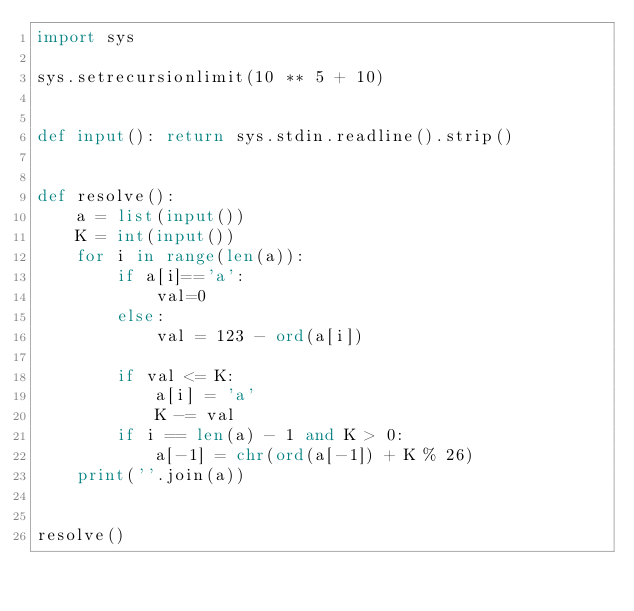<code> <loc_0><loc_0><loc_500><loc_500><_Python_>import sys

sys.setrecursionlimit(10 ** 5 + 10)


def input(): return sys.stdin.readline().strip()


def resolve():
    a = list(input())
    K = int(input())
    for i in range(len(a)):
        if a[i]=='a':
            val=0
        else:
            val = 123 - ord(a[i])

        if val <= K:
            a[i] = 'a'
            K -= val
        if i == len(a) - 1 and K > 0:
            a[-1] = chr(ord(a[-1]) + K % 26)
    print(''.join(a))


resolve()</code> 